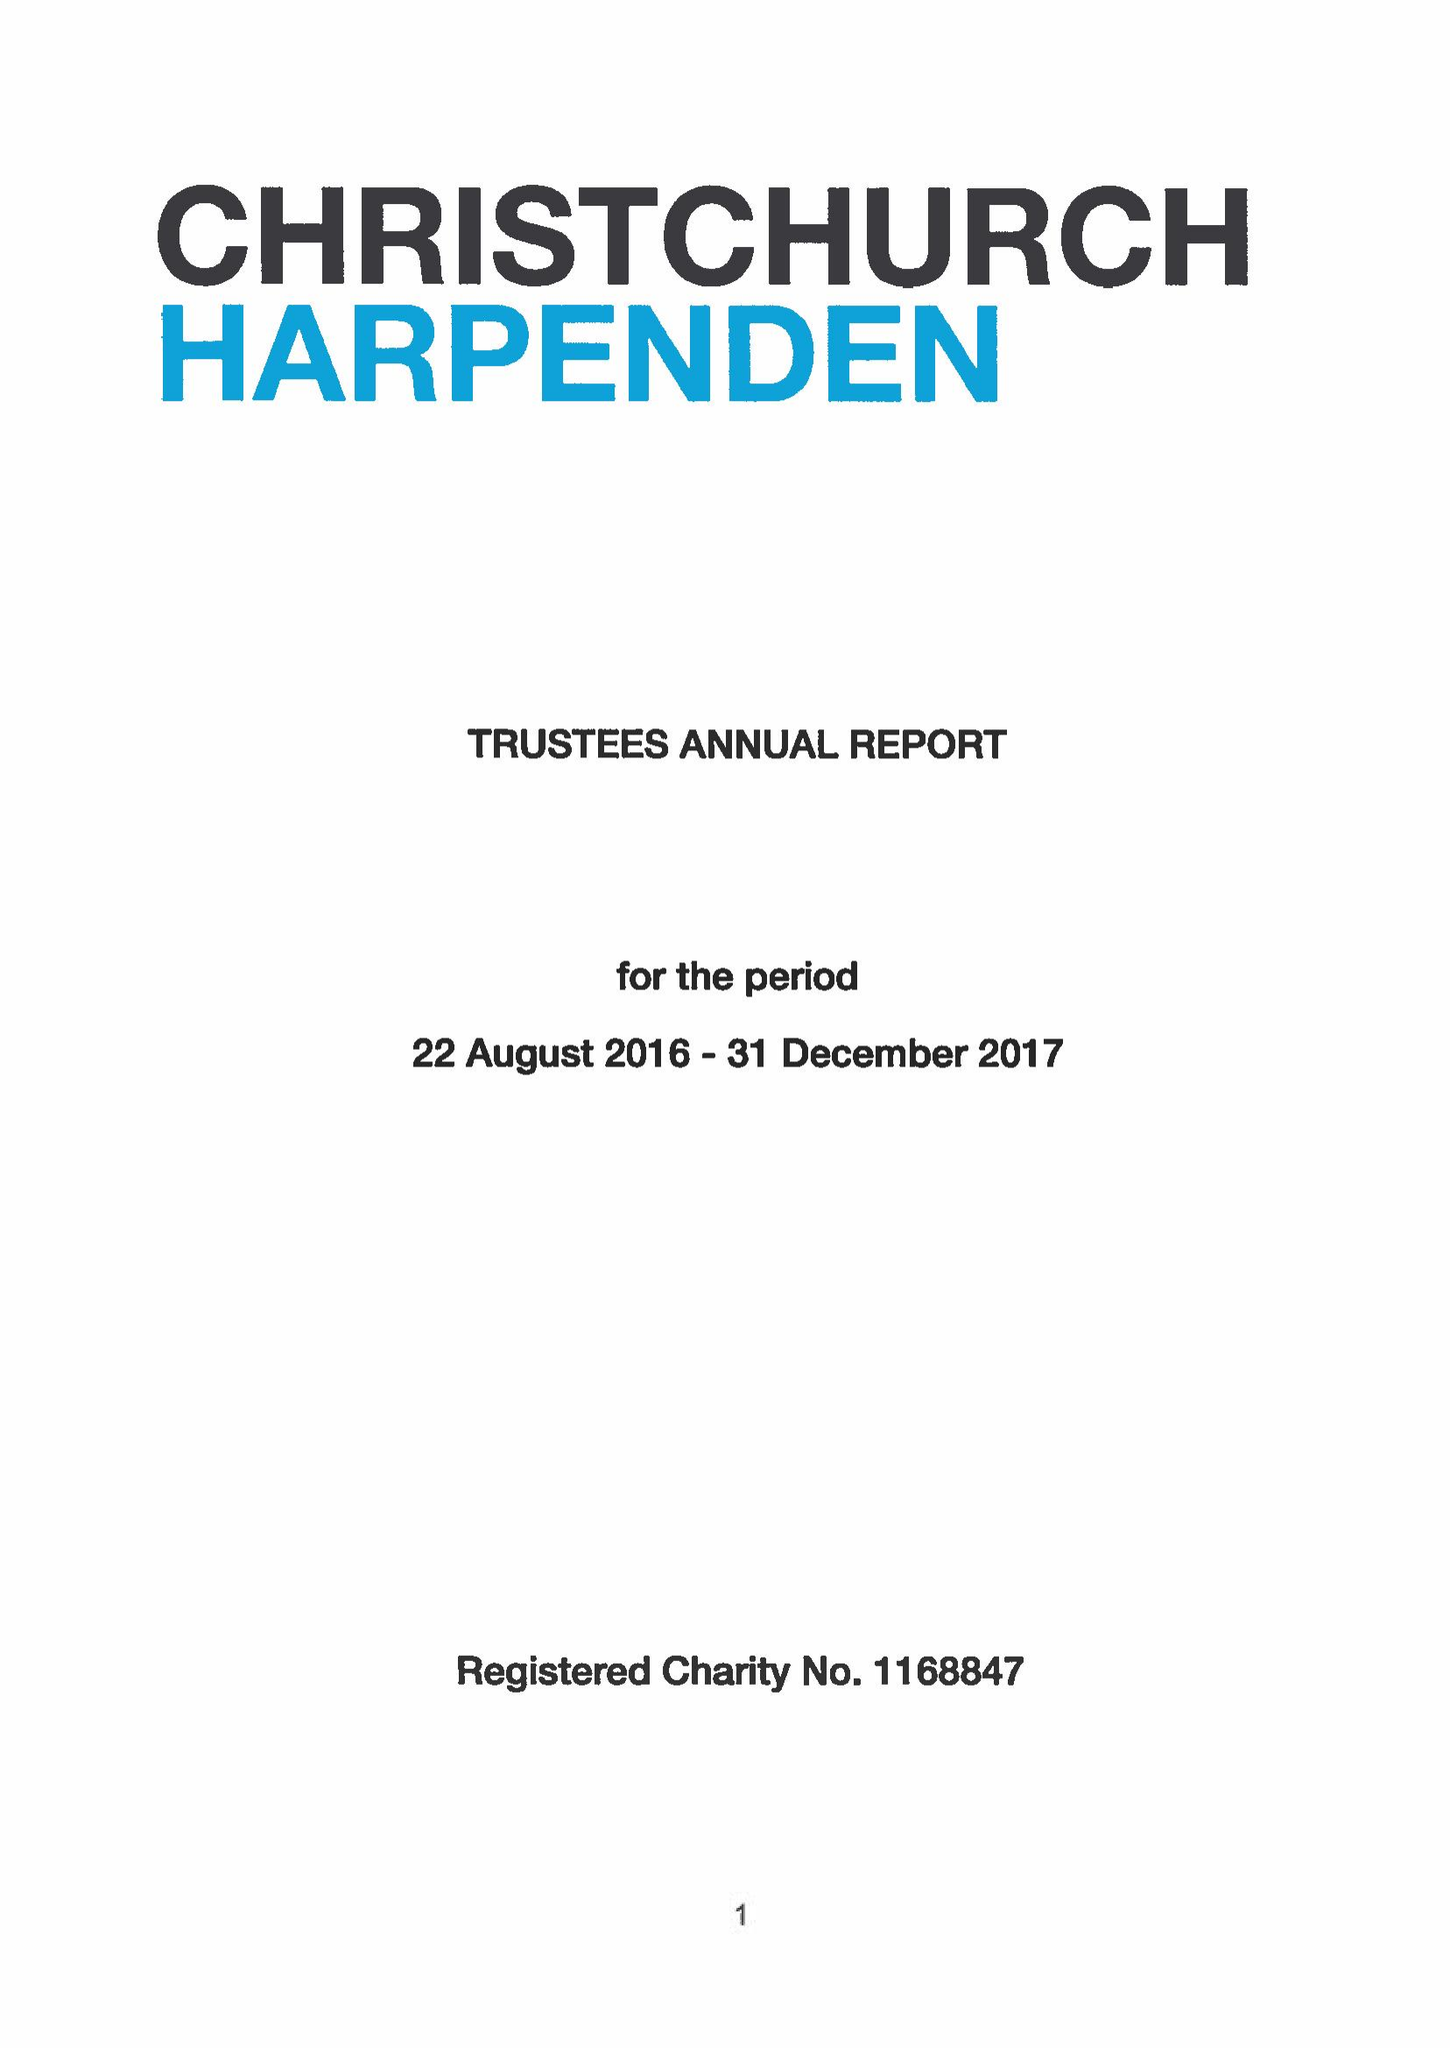What is the value for the charity_name?
Answer the question using a single word or phrase. Christchurch Harpenden 